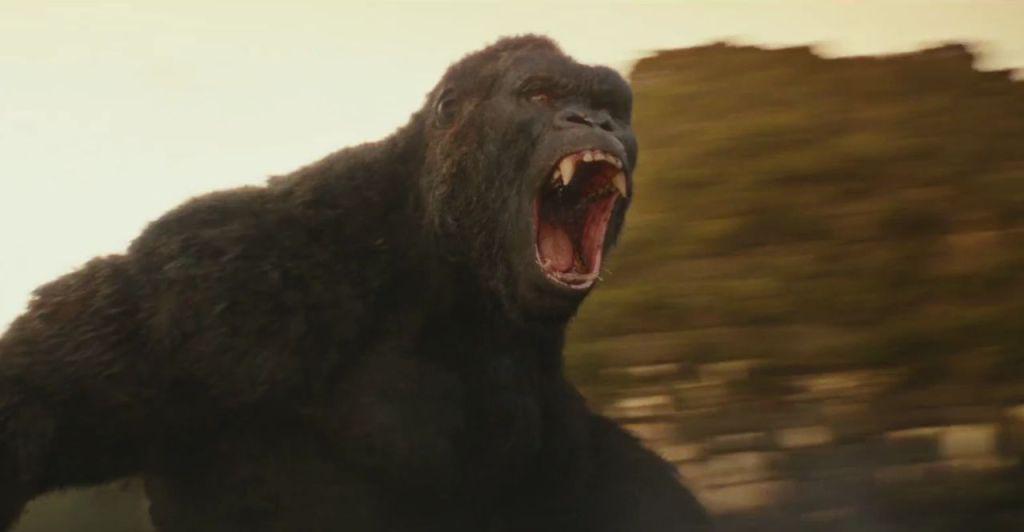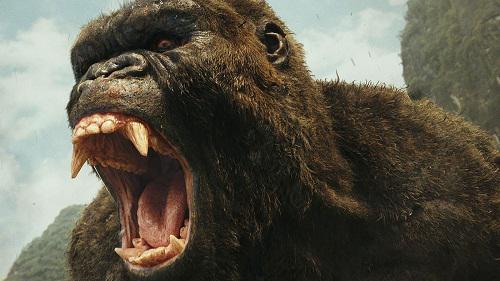The first image is the image on the left, the second image is the image on the right. For the images shown, is this caption "At least one primate is on a log or branch." true? Answer yes or no. No. 